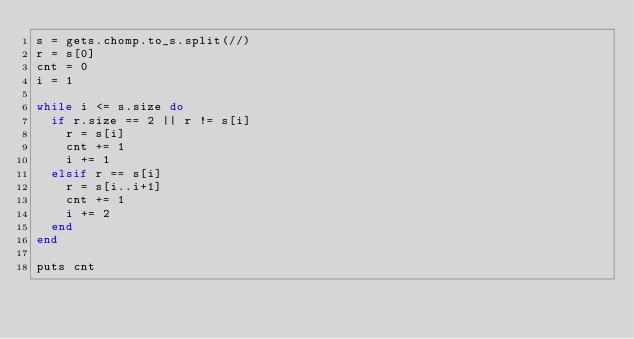<code> <loc_0><loc_0><loc_500><loc_500><_Ruby_>s = gets.chomp.to_s.split(//)
r = s[0]
cnt = 0
i = 1

while i <= s.size do
  if r.size == 2 || r != s[i]
    r = s[i]
    cnt += 1
    i += 1
  elsif r == s[i]
    r = s[i..i+1]
    cnt += 1
    i += 2
  end
end

puts cnt
</code> 